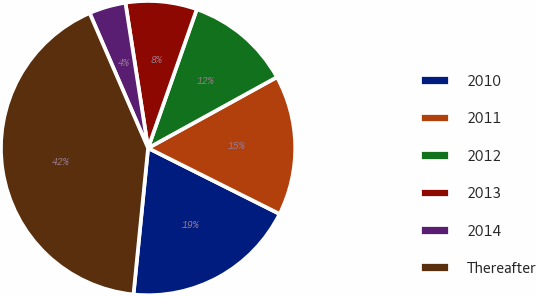Convert chart. <chart><loc_0><loc_0><loc_500><loc_500><pie_chart><fcel>2010<fcel>2011<fcel>2012<fcel>2013<fcel>2014<fcel>Thereafter<nl><fcel>19.19%<fcel>15.4%<fcel>11.62%<fcel>7.83%<fcel>4.04%<fcel>41.91%<nl></chart> 